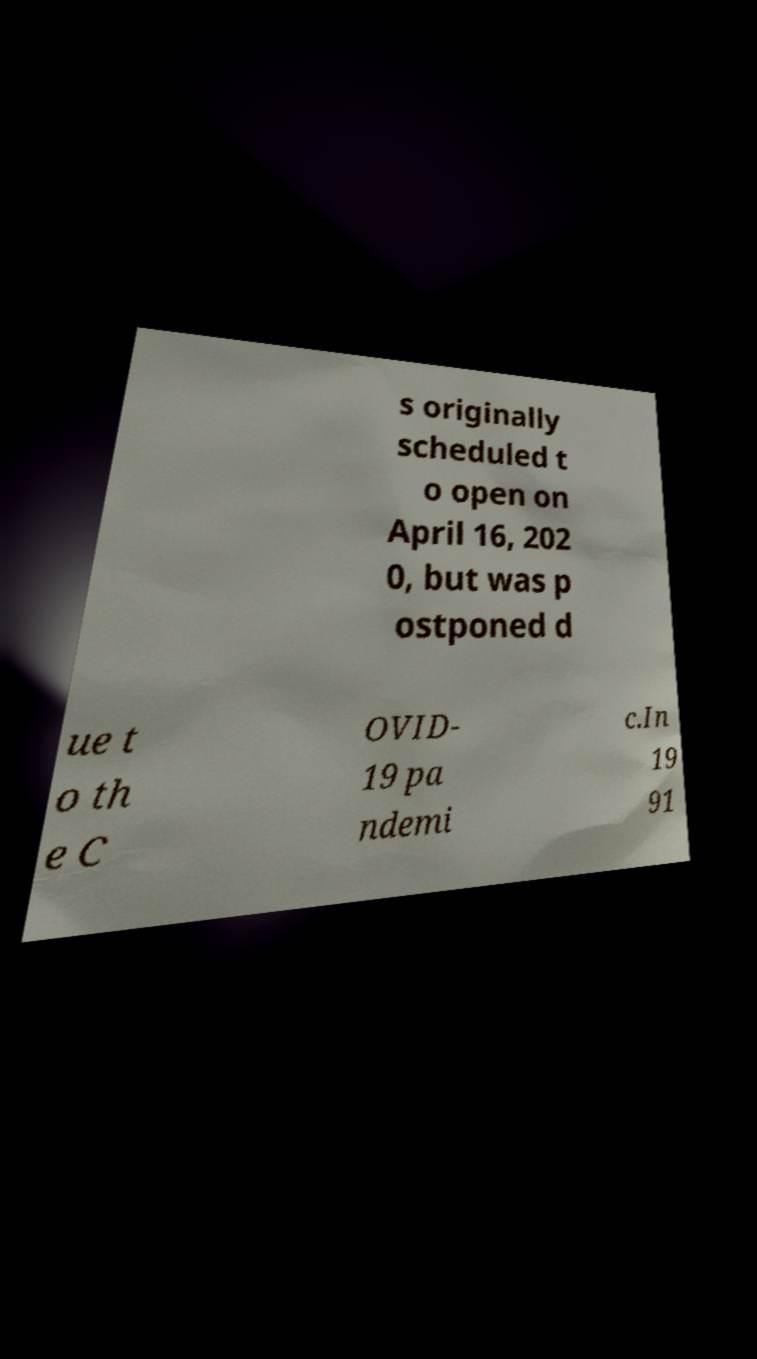Could you assist in decoding the text presented in this image and type it out clearly? s originally scheduled t o open on April 16, 202 0, but was p ostponed d ue t o th e C OVID- 19 pa ndemi c.In 19 91 